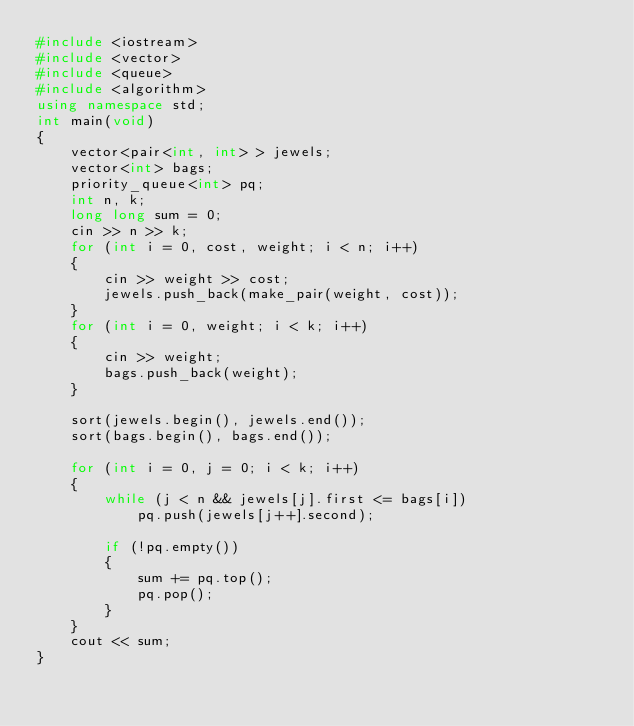<code> <loc_0><loc_0><loc_500><loc_500><_C++_>#include <iostream>
#include <vector>
#include <queue>
#include <algorithm>
using namespace std;
int main(void)
{
	vector<pair<int, int> > jewels;
	vector<int> bags;
	priority_queue<int> pq;
	int n, k;
	long long sum = 0;
	cin >> n >> k;
	for (int i = 0, cost, weight; i < n; i++)
	{
		cin >> weight >> cost;
		jewels.push_back(make_pair(weight, cost));
	}
	for (int i = 0, weight; i < k; i++)
	{
		cin >> weight;
		bags.push_back(weight);
	}

	sort(jewels.begin(), jewels.end());
	sort(bags.begin(), bags.end());
	
	for (int i = 0, j = 0; i < k; i++)
	{
		while (j < n && jewels[j].first <= bags[i])
			pq.push(jewels[j++].second);

		if (!pq.empty())
		{
			sum += pq.top();
			pq.pop();
		}
	}
	cout << sum;
}
</code> 